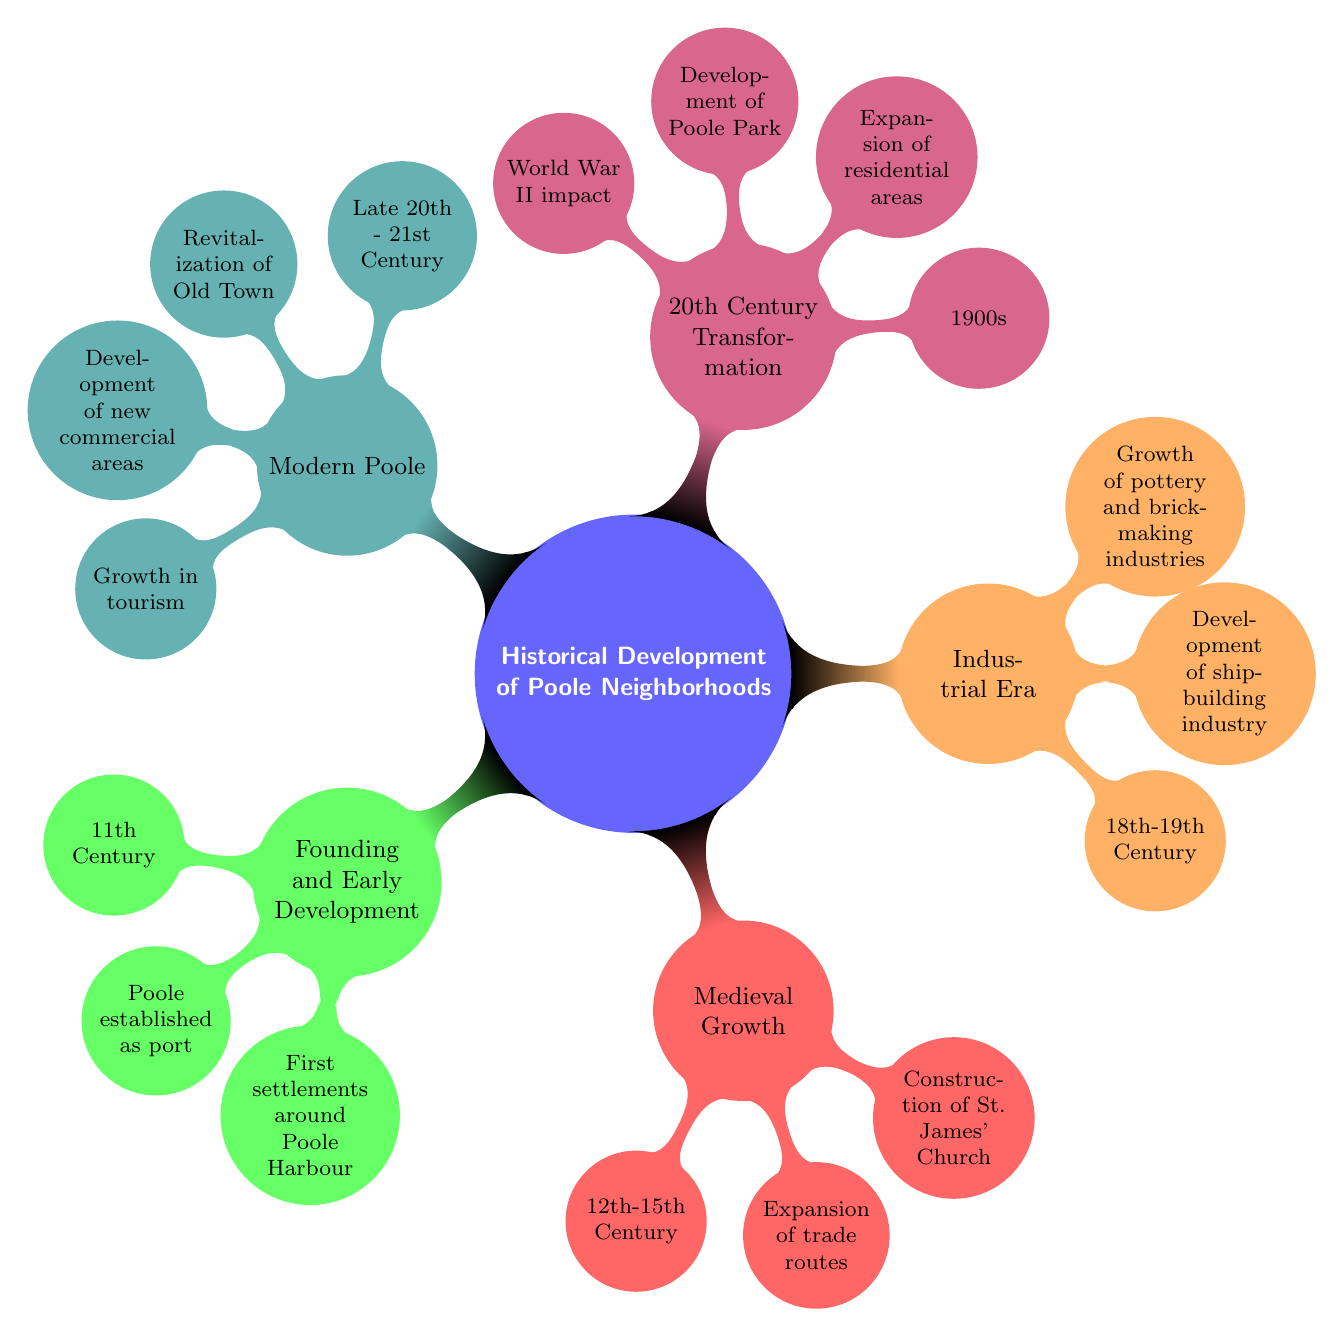What century did Poole establish as a port? The diagram specifies that Poole was established as a port in the 11th Century under the "Founding and Early Development" node.
Answer: 11th Century What major construction occurred between the 12th and 15th centuries? According to the "Medieval Growth" section, the diagram lists the construction of St. James' Church as a significant event during this period.
Answer: St. James' Church Which industries grew during the Industrial Era? The "Industrial Era" node indicates that the shipbuilding industry, along with pottery and brick-making industries, developed during the 18th-19th Century.
Answer: Shipbuilding, pottery, and brick-making What significant impact did World War II have according to the diagram? The diagram notes under "20th Century Transformation" that World War II impacted the expansion of residential areas and other transformations in Poole.
Answer: World War II impact What is one modern development mentioned in the diagram? The "Modern Poole" section highlights the revitalization of the Old Town as one of the key developments in the late 20th to 21st century.
Answer: Revitalization of Old Town How many periods of development does the diagram outline? The diagram has five main nodes, each representing a different period in the historical development of Poole neighborhoods.
Answer: Five In which century did Poole Park develop? The "20th Century Transformation" section indicates that the development of Poole Park occurred in the 1900s, as mentioned along with other significant events.
Answer: 1900s What is the relationship between trade routes and medieval growth? The "Medieval Growth" node mentions the expansion of trade routes specifically as a key point during the 12th to 15th centuries, illustrating their importance to this period's development.
Answer: Expansion of trade routes What distinguishes Modern Poole from previous periods? The "Modern Poole" section emphasizes the growth in tourism as a distinguishing feature when comparing it with earlier historical developments.
Answer: Growth in tourism 